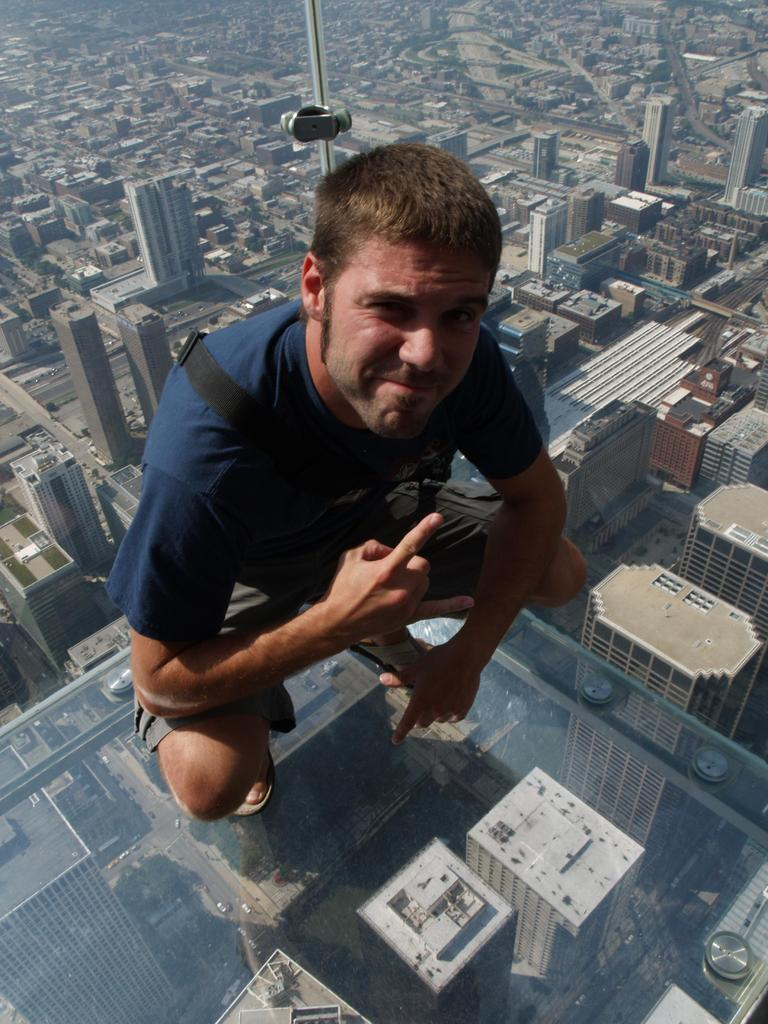What is the person in the image doing? The person is sitting on a glass door in the foreground of the image. What can be seen in the background of the image? There are buildings and houses at the bottom of the image. What type of parcel is being delivered to the store in the image? There is no store or parcel present in the image; it only features a person sitting on a glass door and buildings and houses in the background. 